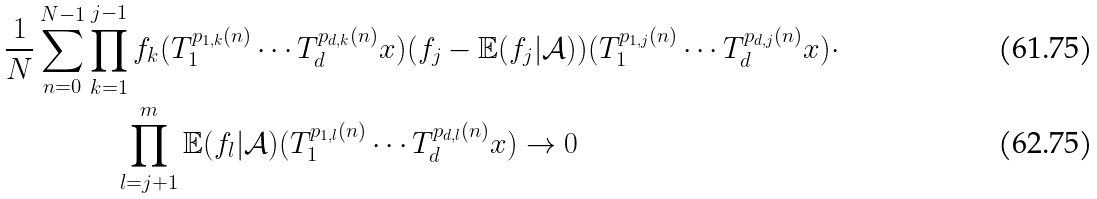Convert formula to latex. <formula><loc_0><loc_0><loc_500><loc_500>\frac { 1 } { N } \sum _ { n = 0 } ^ { N - 1 } & \prod _ { k = 1 } ^ { j - 1 } f _ { k } ( T _ { 1 } ^ { p _ { 1 , k } ( n ) } \cdots T _ { d } ^ { p _ { d , k } ( n ) } x ) ( f _ { j } - \mathbb { E } ( f _ { j } | \mathcal { A } ) ) ( T _ { 1 } ^ { p _ { 1 , j } ( n ) } \cdots T _ { d } ^ { p _ { d , j } ( n ) } x ) \cdot \\ & \quad \prod _ { l = j + 1 } ^ { m } \mathbb { E } ( f _ { l } | \mathcal { A } ) ( T _ { 1 } ^ { p _ { 1 , l } ( n ) } \cdots T _ { d } ^ { p _ { d , l } ( n ) } x ) \rightarrow 0</formula> 